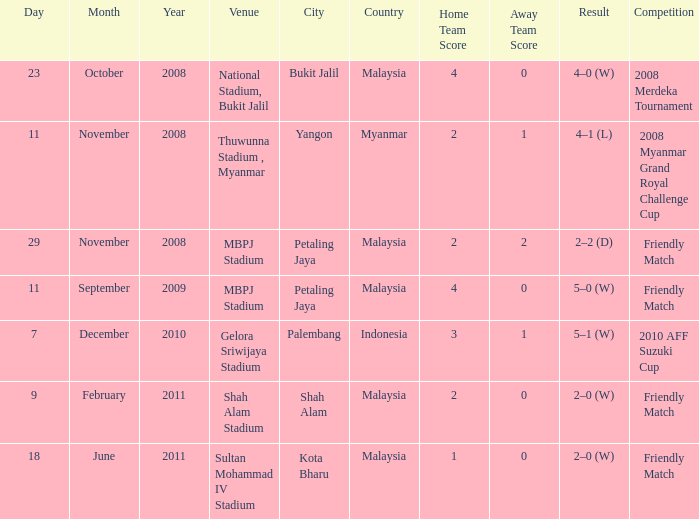What is the Venue of the Competition with a Result of 2–2 (d)? MBPJ Stadium. 